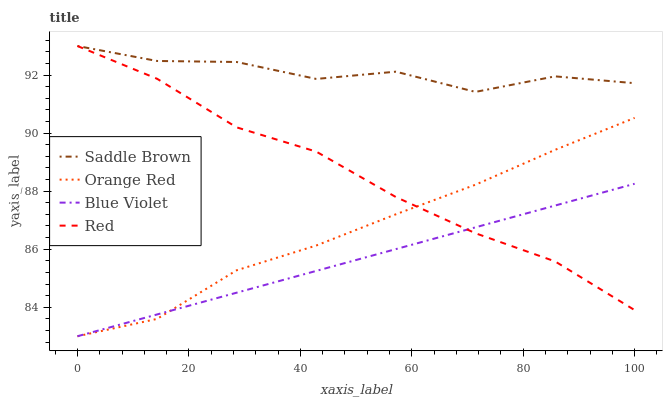Does Blue Violet have the minimum area under the curve?
Answer yes or no. Yes. Does Saddle Brown have the maximum area under the curve?
Answer yes or no. Yes. Does Saddle Brown have the minimum area under the curve?
Answer yes or no. No. Does Blue Violet have the maximum area under the curve?
Answer yes or no. No. Is Blue Violet the smoothest?
Answer yes or no. Yes. Is Saddle Brown the roughest?
Answer yes or no. Yes. Is Saddle Brown the smoothest?
Answer yes or no. No. Is Blue Violet the roughest?
Answer yes or no. No. Does Blue Violet have the lowest value?
Answer yes or no. Yes. Does Saddle Brown have the lowest value?
Answer yes or no. No. Does Saddle Brown have the highest value?
Answer yes or no. Yes. Does Blue Violet have the highest value?
Answer yes or no. No. Is Orange Red less than Saddle Brown?
Answer yes or no. Yes. Is Saddle Brown greater than Orange Red?
Answer yes or no. Yes. Does Blue Violet intersect Orange Red?
Answer yes or no. Yes. Is Blue Violet less than Orange Red?
Answer yes or no. No. Is Blue Violet greater than Orange Red?
Answer yes or no. No. Does Orange Red intersect Saddle Brown?
Answer yes or no. No. 